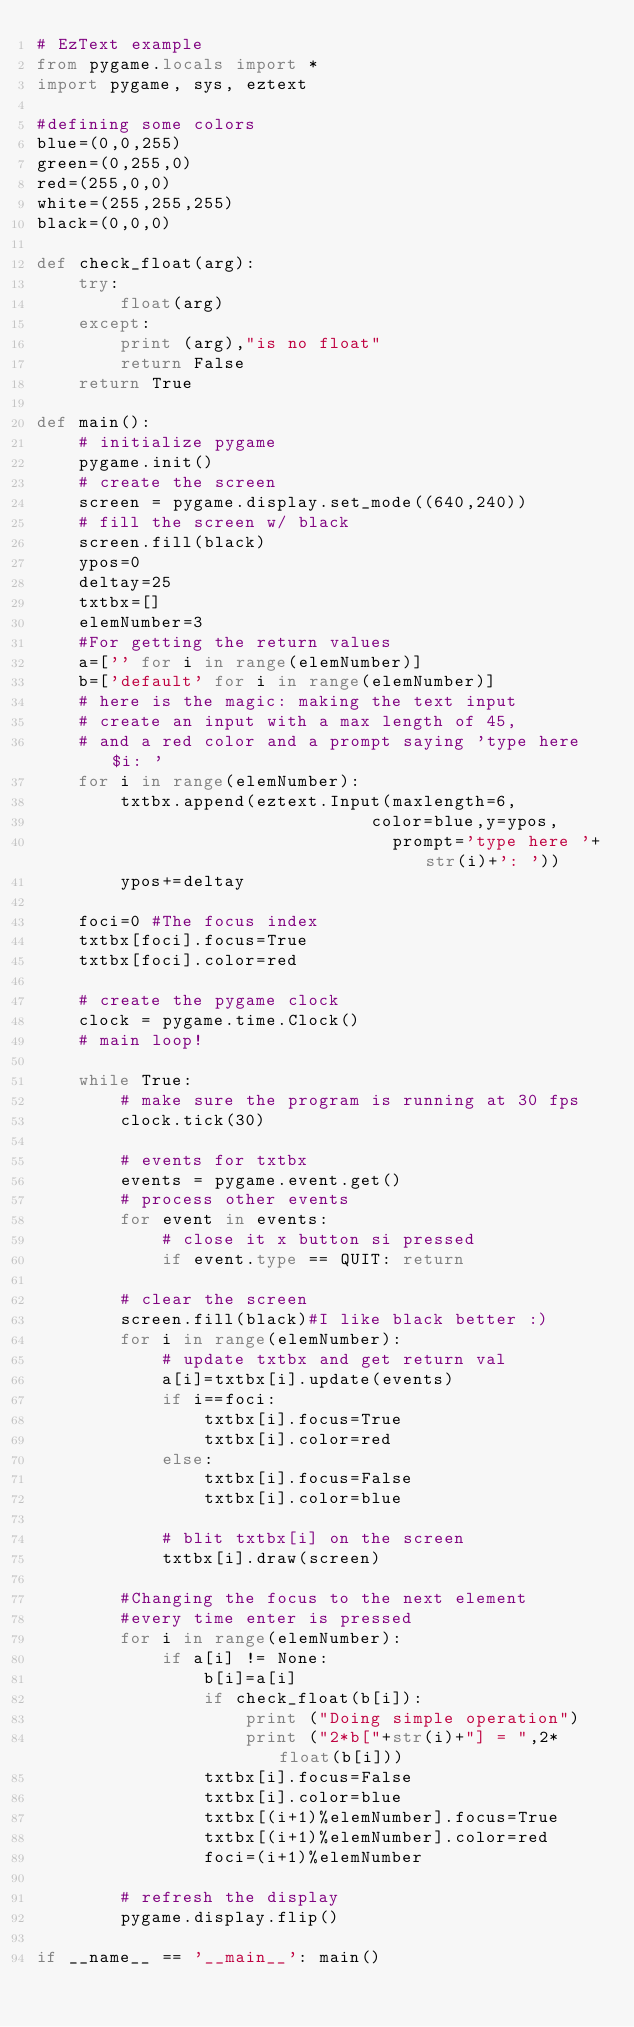<code> <loc_0><loc_0><loc_500><loc_500><_Python_># EzText example
from pygame.locals import *
import pygame, sys, eztext

#defining some colors
blue=(0,0,255)
green=(0,255,0)
red=(255,0,0)
white=(255,255,255)
black=(0,0,0)

def check_float(arg):
    try:
        float(arg)
    except:
        print (arg),"is no float"
        return False
    return True

def main():
    # initialize pygame
    pygame.init()
    # create the screen
    screen = pygame.display.set_mode((640,240))
    # fill the screen w/ black
    screen.fill(black)
    ypos=0
    deltay=25
    txtbx=[]
    elemNumber=3
    #For getting the return values
    a=['' for i in range(elemNumber)]
    b=['default' for i in range(elemNumber)]
    # here is the magic: making the text input
    # create an input with a max length of 45,
    # and a red color and a prompt saying 'type here $i: '
    for i in range(elemNumber):
        txtbx.append(eztext.Input(maxlength=6,
                                color=blue,y=ypos,
                                  prompt='type here '+str(i)+': '))
        ypos+=deltay

    foci=0 #The focus index
    txtbx[foci].focus=True
    txtbx[foci].color=red

    # create the pygame clock
    clock = pygame.time.Clock()
    # main loop!

    while True:
        # make sure the program is running at 30 fps
        clock.tick(30)

        # events for txtbx
        events = pygame.event.get()
        # process other events
        for event in events:
            # close it x button si pressed
            if event.type == QUIT: return

        # clear the screen
        screen.fill(black)#I like black better :)
        for i in range(elemNumber):
            # update txtbx and get return val
            a[i]=txtbx[i].update(events)
            if i==foci:
                txtbx[i].focus=True
                txtbx[i].color=red
            else:
                txtbx[i].focus=False
                txtbx[i].color=blue
                
            # blit txtbx[i] on the screen
            txtbx[i].draw(screen)

        #Changing the focus to the next element 
        #every time enter is pressed
        for i in range(elemNumber):
            if a[i] != None:
                b[i]=a[i]
                if check_float(b[i]):
                    print ("Doing simple operation")
                    print ("2*b["+str(i)+"] = ",2*float(b[i]))
                txtbx[i].focus=False
                txtbx[i].color=blue
                txtbx[(i+1)%elemNumber].focus=True
                txtbx[(i+1)%elemNumber].color=red
                foci=(i+1)%elemNumber

        # refresh the display
        pygame.display.flip()

if __name__ == '__main__': main()
</code> 